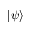Convert formula to latex. <formula><loc_0><loc_0><loc_500><loc_500>| \psi \rangle</formula> 